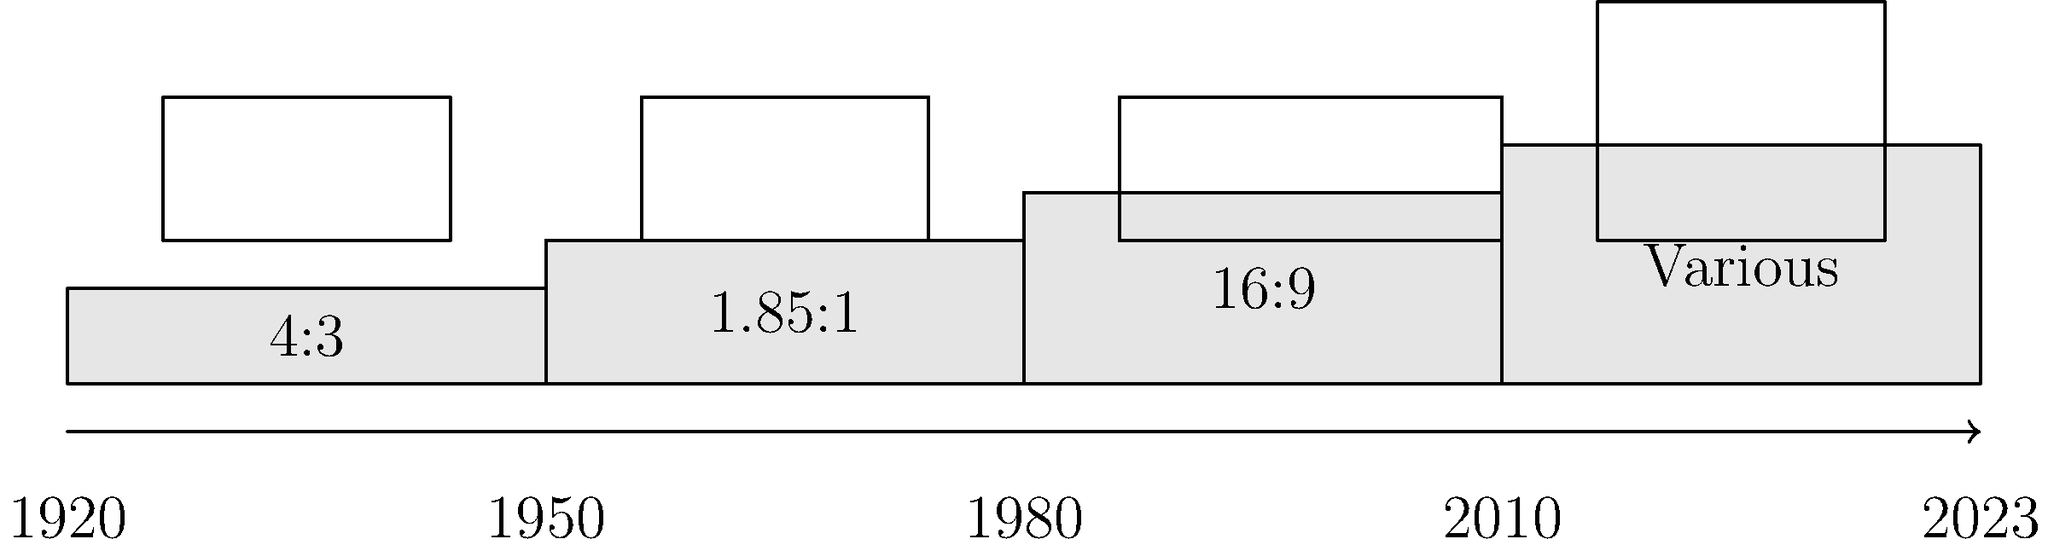Analyze the evolution of documentary film aspect ratios from 1920 to 2023, as depicted in the timeline. How have technological advancements and audience preferences influenced these changes, and what implications do these shifts have for documentary filmmakers in terms of composition and storytelling? 1. 1920-1950: The dominant aspect ratio was 4:3 (1.33:1), which was standard for early film and television.
   - This ratio was influenced by the limitations of early film technology and the shape of television screens.
   - It provided a nearly square frame, suitable for both close-ups and wider shots.

2. 1950-1980: The introduction of widescreen formats, particularly 1.85:1, became popular.
   - This shift was driven by the film industry's need to compete with television by offering a more immersive experience.
   - Documentarians began to experiment with wider frames, allowing for more expansive landscapes and group shots.

3. 1980-2010: The 16:9 (1.78:1) aspect ratio gained prominence, especially with the advent of HDTV.
   - This format offered a compromise between traditional TV and widescreen cinema ratios.
   - It provided documentary filmmakers with a versatile frame that worked well for both TV broadcast and theatrical presentation.

4. 2010-2023: Various aspect ratios are now used, including ultra-wide formats and even vertical video.
   - Digital technology has made it easier to shoot and distribute in multiple formats.
   - The rise of online streaming and mobile devices has influenced aspect ratio choices, with some documentaries even using dynamic ratios that change within the film.

Implications for documentary filmmakers:
- Composition: Filmmakers must now consider how their shots will appear across multiple platforms and aspect ratios.
- Storytelling: Different ratios can be used to enhance narrative elements (e.g., using wider ratios for landscapes, tighter ratios for intimate interviews).
- Audience engagement: Aspect ratio choices can affect how viewers connect with the content, especially on different viewing devices.
- Historical context: When using archival footage, filmmakers must consider how to integrate older aspect ratios into modern presentations.
- Artistic expression: The variety of available ratios allows for more creative freedom in visual storytelling.
Answer: Documentary aspect ratios evolved from 4:3 (1920-1950) to widescreen 1.85:1 (1950-1980), then 16:9 (1980-2010), and now various ratios (2010-2023), influenced by technology and viewing habits, impacting composition and storytelling techniques. 